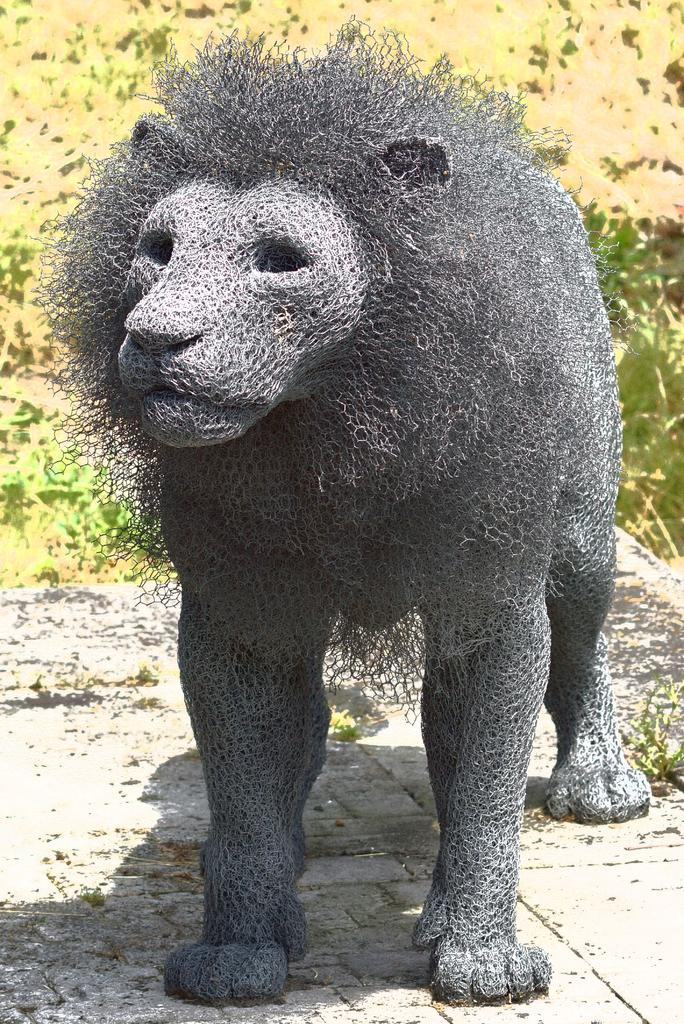What is the main subject of the image? The main subject of the image is a sculpture made with metal mesh. How is the sculpture positioned in the image? The sculpture is placed on the ground. What can be seen in the background of the image? There are plants in the background of the image. What type of country is depicted in the image? There is no country depicted in the image; it features a metal mesh sculpture and plants in the background. How many bears are visible in the image? There are no bears present in the image. 